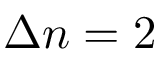Convert formula to latex. <formula><loc_0><loc_0><loc_500><loc_500>\Delta n = 2</formula> 